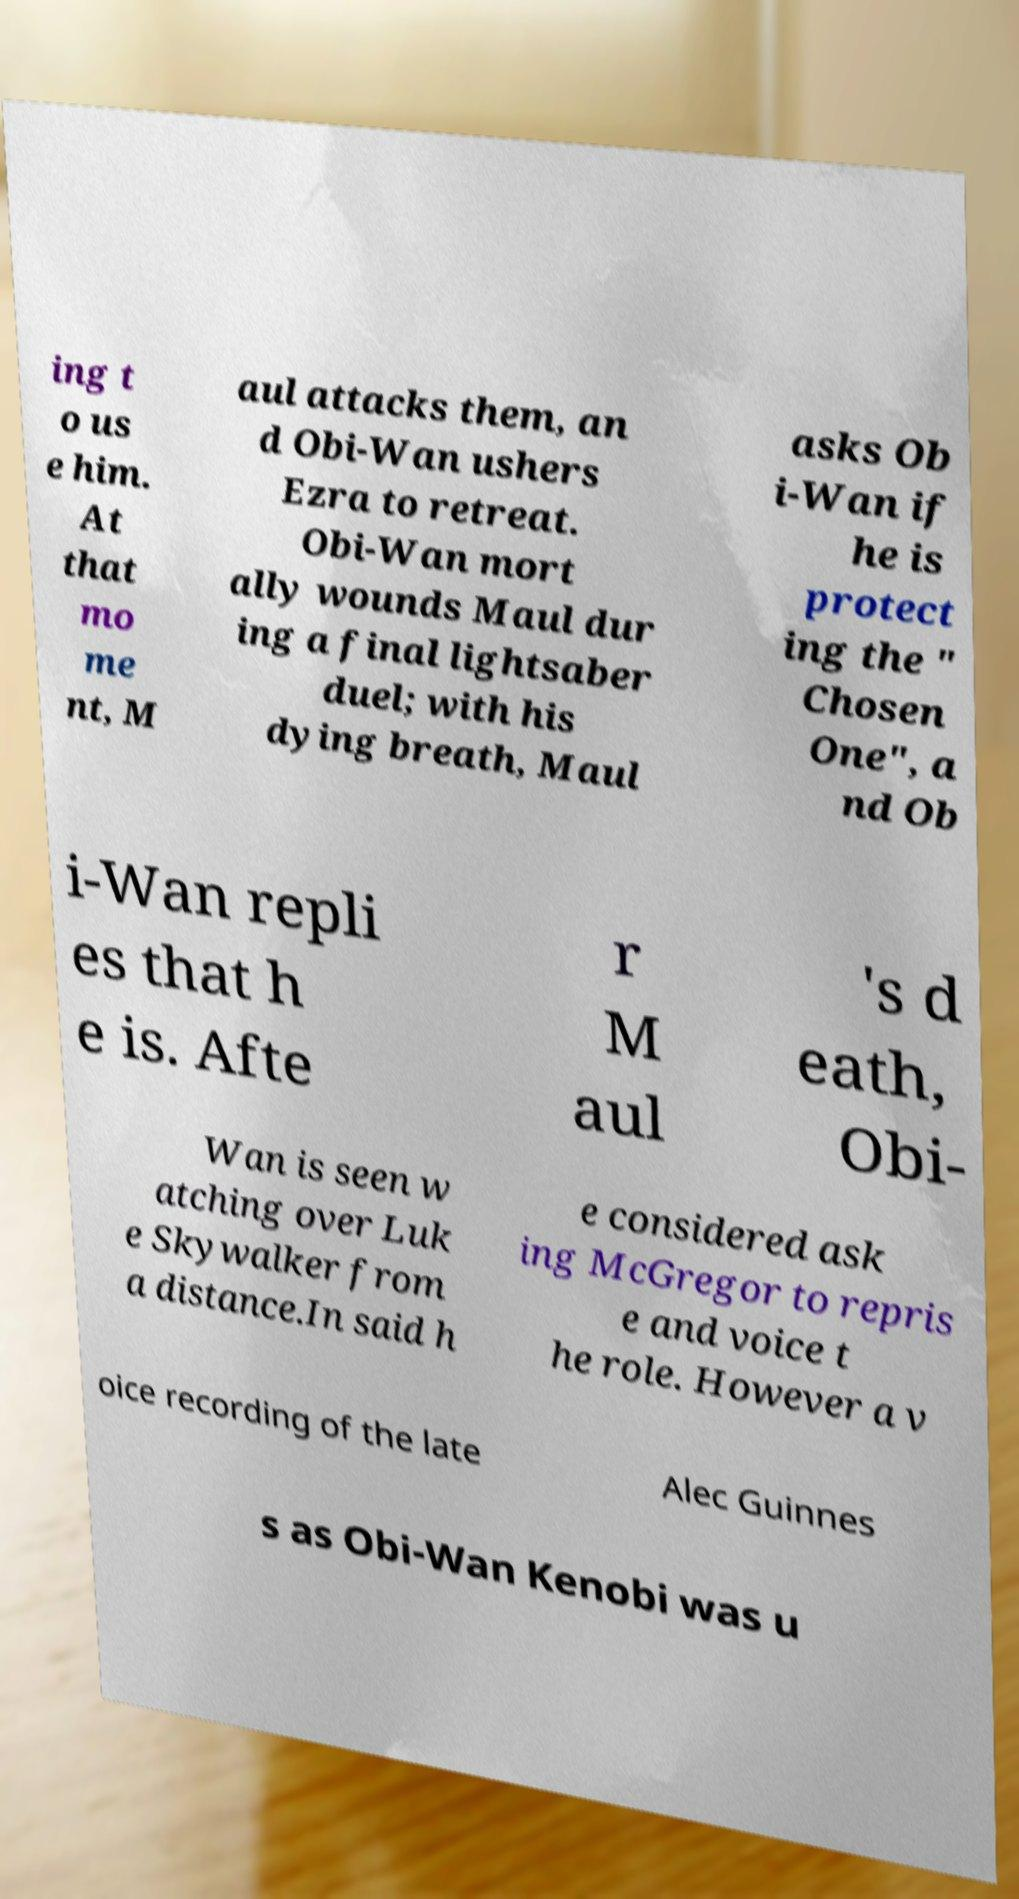There's text embedded in this image that I need extracted. Can you transcribe it verbatim? ing t o us e him. At that mo me nt, M aul attacks them, an d Obi-Wan ushers Ezra to retreat. Obi-Wan mort ally wounds Maul dur ing a final lightsaber duel; with his dying breath, Maul asks Ob i-Wan if he is protect ing the " Chosen One", a nd Ob i-Wan repli es that h e is. Afte r M aul 's d eath, Obi- Wan is seen w atching over Luk e Skywalker from a distance.In said h e considered ask ing McGregor to repris e and voice t he role. However a v oice recording of the late Alec Guinnes s as Obi-Wan Kenobi was u 